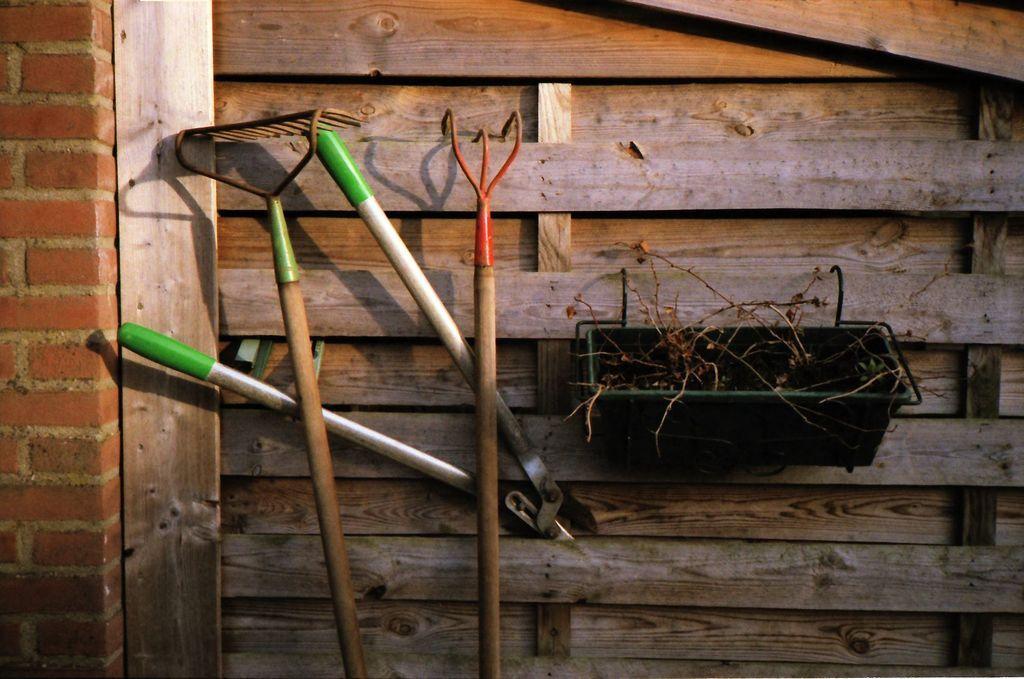Could you give a brief overview of what you see in this image? In this picture we can see few tools, basket and wooden wall. 